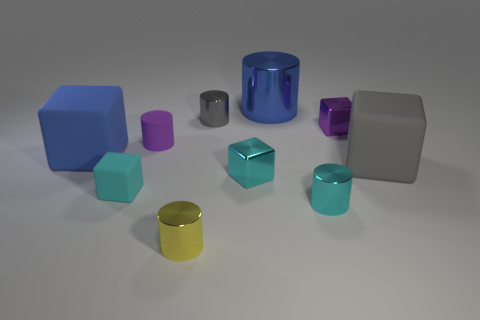Do the objects seem to be made of the same material or different ones? The objects appear to be made from different materials. For instance, the large blue and pink cubes have a matte finish suggesting a rubbery texture, while the cylinders and the gray cube exhibit a reflective surface indicative of metal or plastic-like materials. 